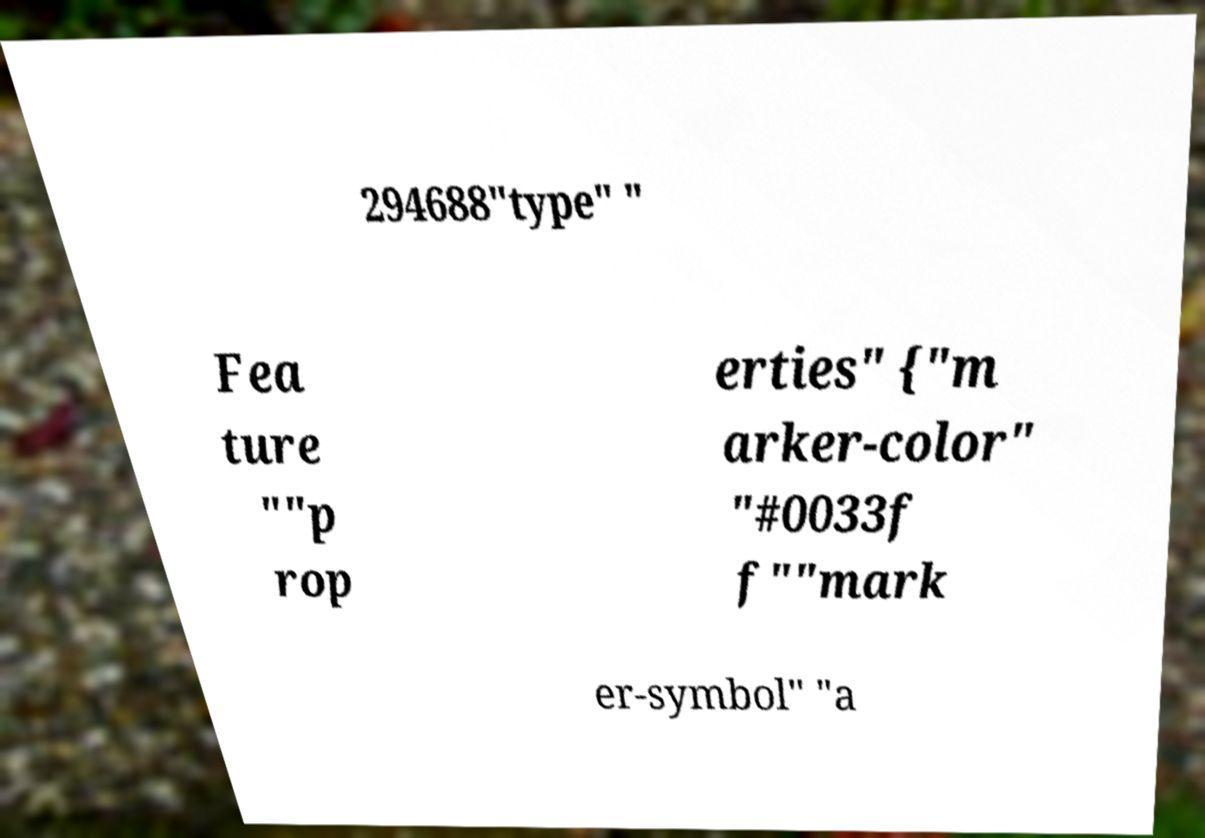I need the written content from this picture converted into text. Can you do that? 294688"type" " Fea ture ""p rop erties" {"m arker-color" "#0033f f""mark er-symbol" "a 